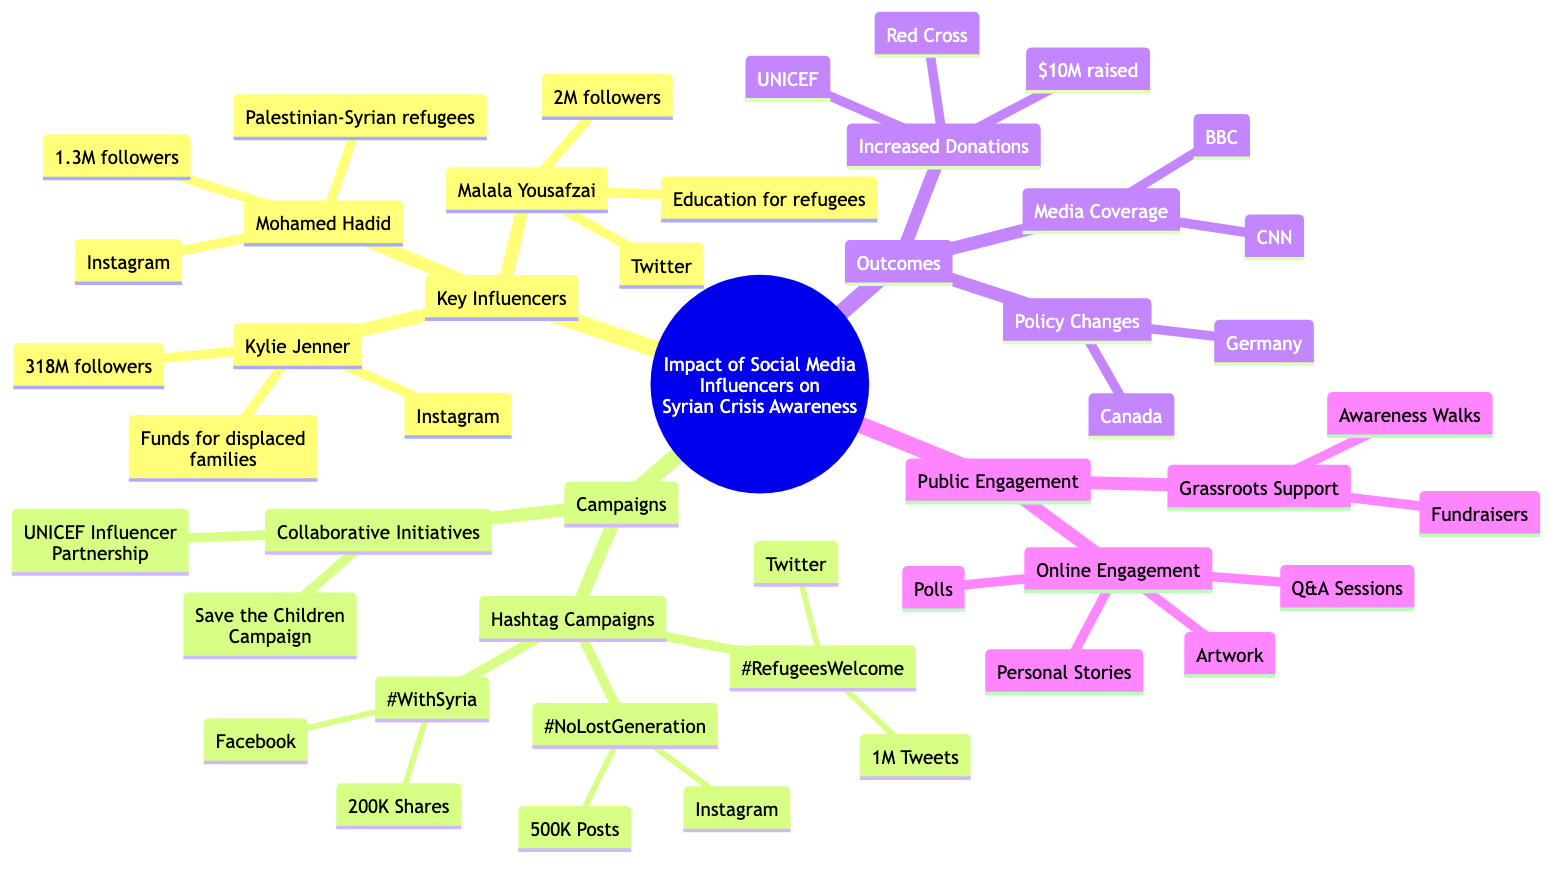What is the total amount raised through influencer campaigns? The diagram indicates under the "Outcomes" section that the total amount raised is $10M.
Answer: $10M Who is the influencer advocating for education specifically aimed at Syrian refugee children? The key influencer listed for promoting education for Syrian refugee children is Malala Yousafzai, as noted in the "Key Influencers" section.
Answer: Malala Yousafzai How many followers does Kylie Jenner have on Instagram? According to the "Key Influencers" part of the diagram, it states Kylie Jenner has 318M followers.
Answer: 318M What campaign reached 1 million tweets? The "Hashtag Campaigns" section mentions that the #RefugeesWelcome campaign reached 1M tweets.
Answer: #RefugeesWelcome Which two countries made policy changes regarding refugee support? The "Policy Changes" under the "Outcomes" section lists Germany and Canada as the countries that improved their refugee intake and support policies.
Answer: Germany, Canada What type of initiatives did influencers collaborate on to raise awareness and funds for Syrian children? The diagram lists "Collaborative Initiatives" and specifically mentions the UNICEF Influencer Partnership as one type of initiative that involves various influencers.
Answer: UNICEF Influencer Partnership What is the objective of the #WithSyria campaign? The objective of the #WithSyria campaign, found in the "Hashtag Campaigns" section, is stated to be showing solidarity with Syrian crisis victims.
Answer: Show solidarity with Syrian crisis victims What forms of online engagement are mentioned in the Public Engagement section? The "Online Engagement" part lists "Polls," "Q&A Sessions," "Personal Stories," and "Artwork" as forms of engagement, indicating various interactive methods to involve people.
Answer: Polls, Q&A Sessions, Personal Stories, Artwork What is the reach of the #NoLostGeneration campaign on Instagram? The diagram states that the #NoLostGeneration campaign reached 500K posts under the "Hashtag Campaigns" section.
Answer: 500K Posts 